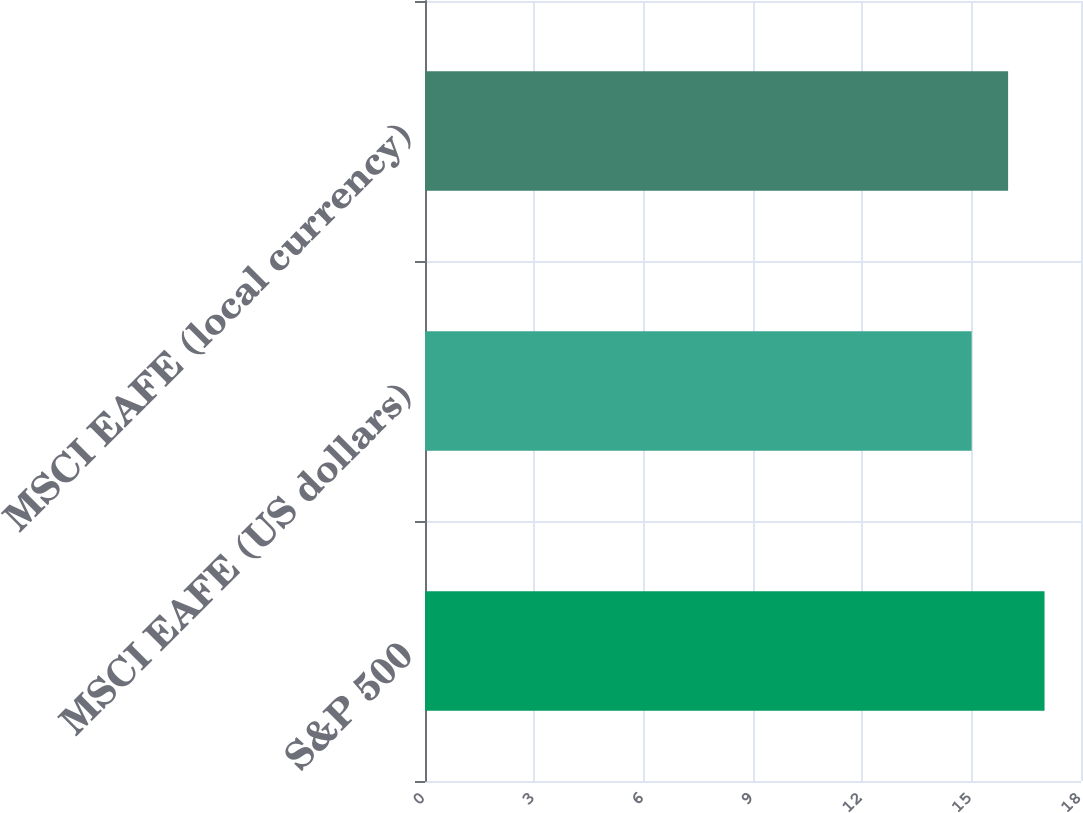Convert chart to OTSL. <chart><loc_0><loc_0><loc_500><loc_500><bar_chart><fcel>S&P 500<fcel>MSCI EAFE (US dollars)<fcel>MSCI EAFE (local currency)<nl><fcel>17<fcel>15<fcel>16<nl></chart> 